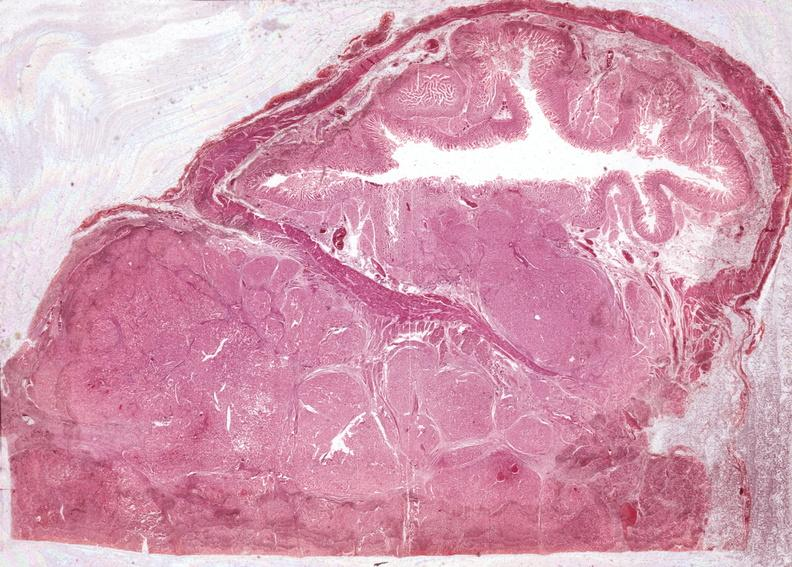what does this image show?
Answer the question using a single word or phrase. Islet cell carcinoma 